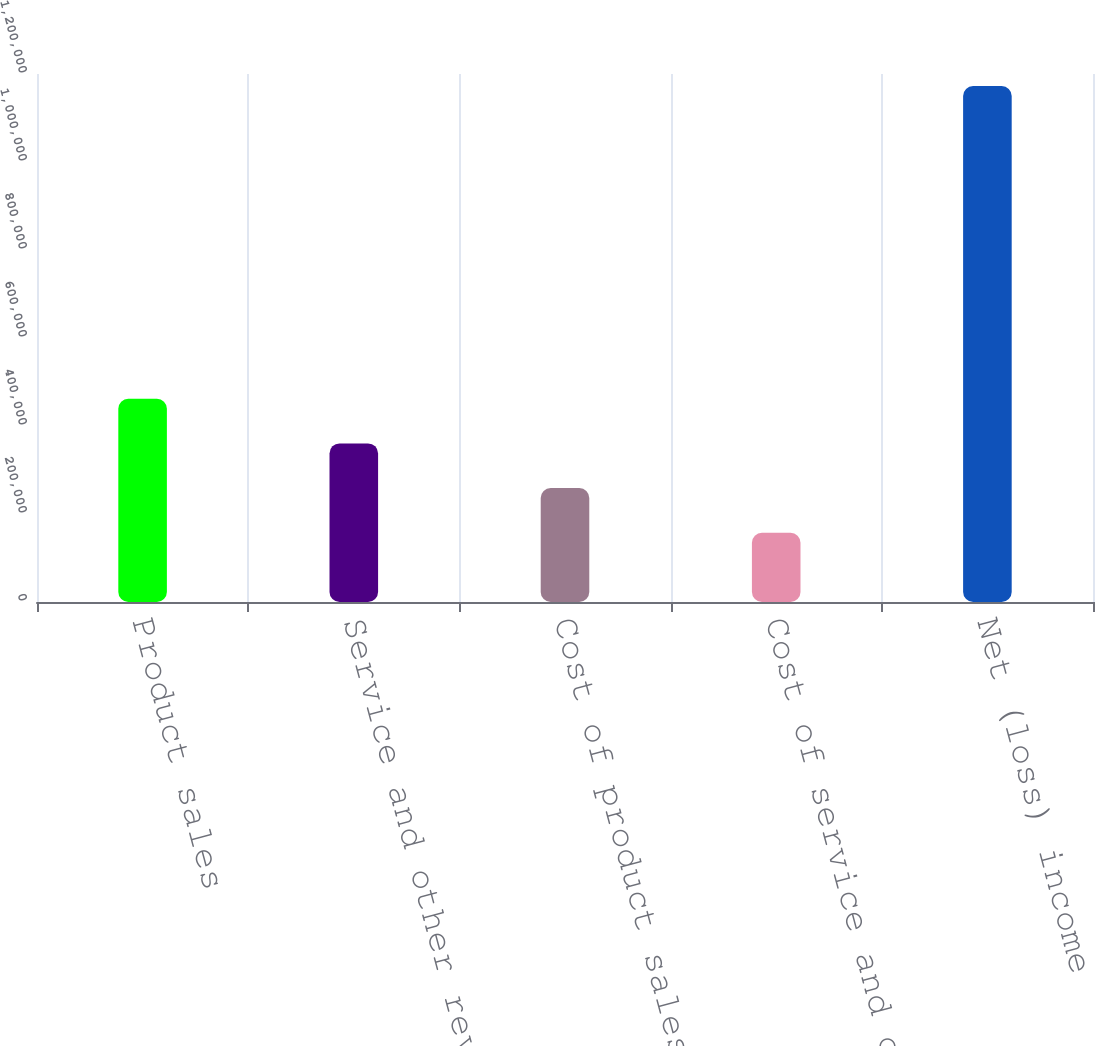<chart> <loc_0><loc_0><loc_500><loc_500><bar_chart><fcel>Product sales<fcel>Service and other revenues<fcel>Cost of product sales<fcel>Cost of service and other<fcel>Net (loss) income<nl><fcel>462025<fcel>360480<fcel>258936<fcel>157391<fcel>1.17284e+06<nl></chart> 